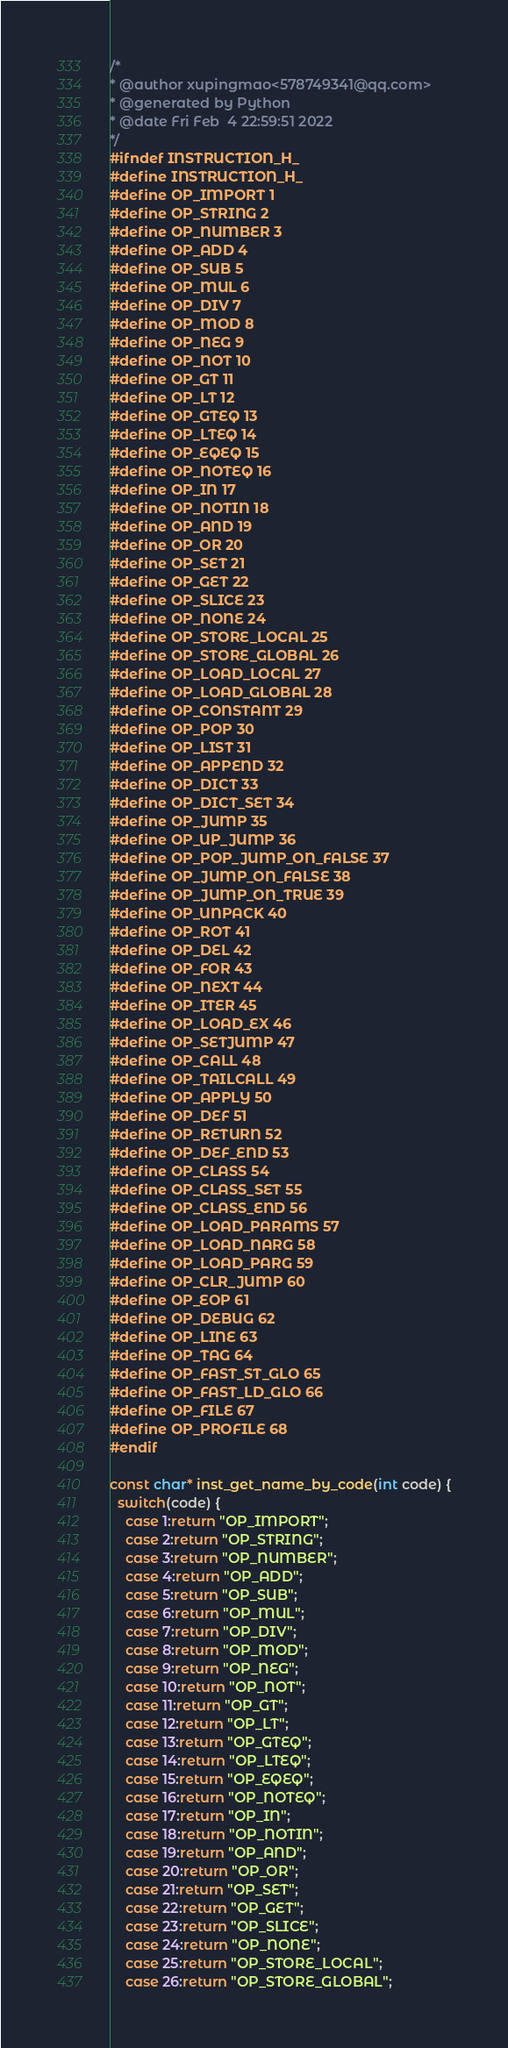<code> <loc_0><loc_0><loc_500><loc_500><_C_>/*
* @author xupingmao<578749341@qq.com>
* @generated by Python
* @date Fri Feb  4 22:59:51 2022
*/
#ifndef INSTRUCTION_H_
#define INSTRUCTION_H_
#define OP_IMPORT 1
#define OP_STRING 2
#define OP_NUMBER 3
#define OP_ADD 4
#define OP_SUB 5
#define OP_MUL 6
#define OP_DIV 7
#define OP_MOD 8
#define OP_NEG 9
#define OP_NOT 10
#define OP_GT 11
#define OP_LT 12
#define OP_GTEQ 13
#define OP_LTEQ 14
#define OP_EQEQ 15
#define OP_NOTEQ 16
#define OP_IN 17
#define OP_NOTIN 18
#define OP_AND 19
#define OP_OR 20
#define OP_SET 21
#define OP_GET 22
#define OP_SLICE 23
#define OP_NONE 24
#define OP_STORE_LOCAL 25
#define OP_STORE_GLOBAL 26
#define OP_LOAD_LOCAL 27
#define OP_LOAD_GLOBAL 28
#define OP_CONSTANT 29
#define OP_POP 30
#define OP_LIST 31
#define OP_APPEND 32
#define OP_DICT 33
#define OP_DICT_SET 34
#define OP_JUMP 35
#define OP_UP_JUMP 36
#define OP_POP_JUMP_ON_FALSE 37
#define OP_JUMP_ON_FALSE 38
#define OP_JUMP_ON_TRUE 39
#define OP_UNPACK 40
#define OP_ROT 41
#define OP_DEL 42
#define OP_FOR 43
#define OP_NEXT 44
#define OP_ITER 45
#define OP_LOAD_EX 46
#define OP_SETJUMP 47
#define OP_CALL 48
#define OP_TAILCALL 49
#define OP_APPLY 50
#define OP_DEF 51
#define OP_RETURN 52
#define OP_DEF_END 53
#define OP_CLASS 54
#define OP_CLASS_SET 55
#define OP_CLASS_END 56
#define OP_LOAD_PARAMS 57
#define OP_LOAD_NARG 58
#define OP_LOAD_PARG 59
#define OP_CLR_JUMP 60
#define OP_EOP 61
#define OP_DEBUG 62
#define OP_LINE 63
#define OP_TAG 64
#define OP_FAST_ST_GLO 65
#define OP_FAST_LD_GLO 66
#define OP_FILE 67
#define OP_PROFILE 68
#endif

const char* inst_get_name_by_code(int code) {
  switch(code) {
    case 1:return "OP_IMPORT";
    case 2:return "OP_STRING";
    case 3:return "OP_NUMBER";
    case 4:return "OP_ADD";
    case 5:return "OP_SUB";
    case 6:return "OP_MUL";
    case 7:return "OP_DIV";
    case 8:return "OP_MOD";
    case 9:return "OP_NEG";
    case 10:return "OP_NOT";
    case 11:return "OP_GT";
    case 12:return "OP_LT";
    case 13:return "OP_GTEQ";
    case 14:return "OP_LTEQ";
    case 15:return "OP_EQEQ";
    case 16:return "OP_NOTEQ";
    case 17:return "OP_IN";
    case 18:return "OP_NOTIN";
    case 19:return "OP_AND";
    case 20:return "OP_OR";
    case 21:return "OP_SET";
    case 22:return "OP_GET";
    case 23:return "OP_SLICE";
    case 24:return "OP_NONE";
    case 25:return "OP_STORE_LOCAL";
    case 26:return "OP_STORE_GLOBAL";</code> 